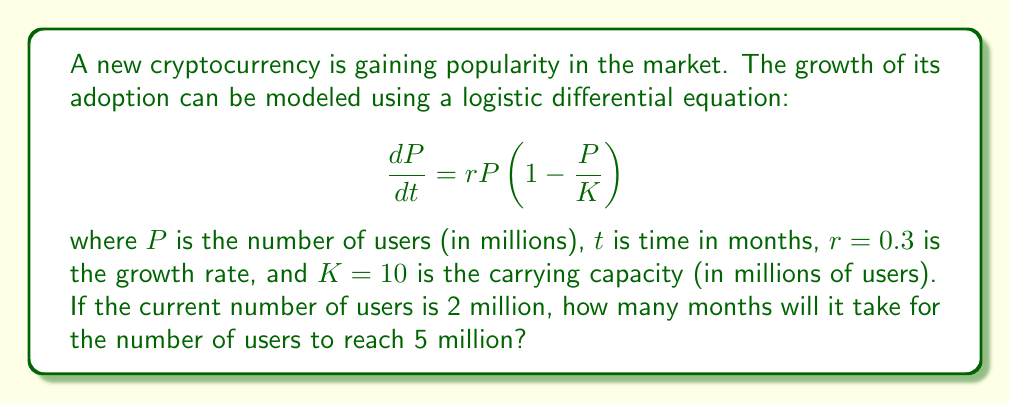Could you help me with this problem? To solve this problem, we need to use the solution to the logistic differential equation and solve for time $t$. The steps are as follows:

1) The solution to the logistic differential equation is:

   $$P(t) = \frac{K}{1 + (\frac{K}{P_0} - 1)e^{-rt}}$$

   where $P_0$ is the initial population.

2) We're given:
   $K = 10$ million users
   $r = 0.3$ per month
   $P_0 = 2$ million users
   We want to find $t$ when $P(t) = 5$ million users

3) Substituting these values into the equation:

   $$5 = \frac{10}{1 + (\frac{10}{2} - 1)e^{-0.3t}}$$

4) Simplify:

   $$5 = \frac{10}{1 + 4e^{-0.3t}}$$

5) Multiply both sides by $(1 + 4e^{-0.3t})$:

   $$5(1 + 4e^{-0.3t}) = 10$$

6) Distribute:

   $$5 + 20e^{-0.3t} = 10$$

7) Subtract 5 from both sides:

   $$20e^{-0.3t} = 5$$

8) Divide both sides by 20:

   $$e^{-0.3t} = 0.25$$

9) Take the natural log of both sides:

   $$-0.3t = \ln(0.25)$$

10) Divide both sides by -0.3:

    $$t = \frac{\ln(0.25)}{-0.3} \approx 4.62$$

Therefore, it will take approximately 4.62 months for the number of users to reach 5 million.
Answer: 4.62 months 